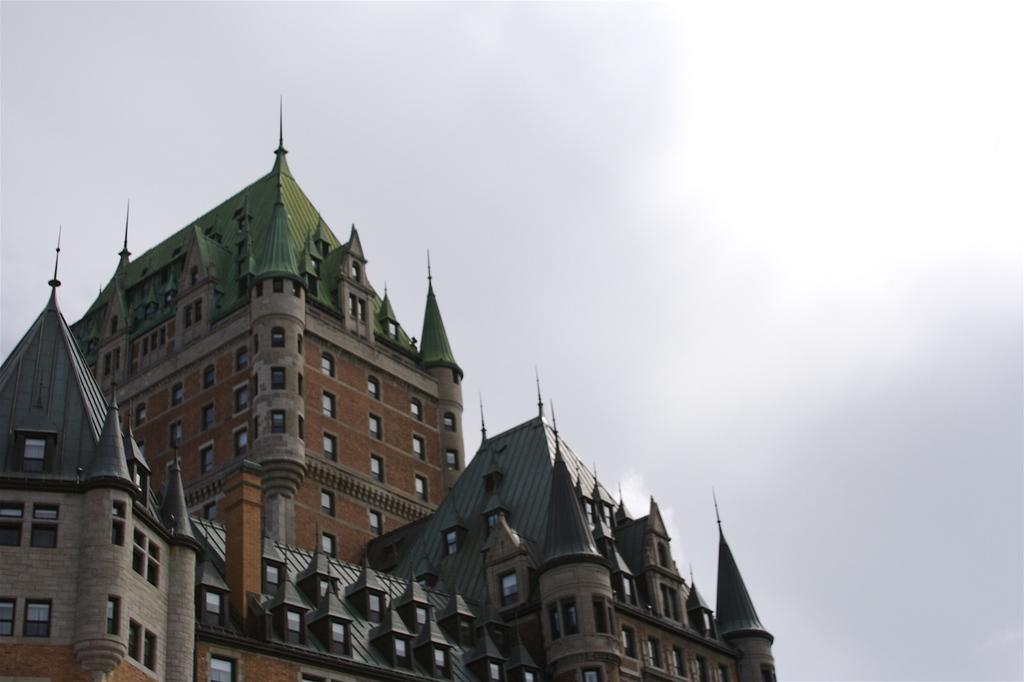How would you summarize this image in a sentence or two? In this image, there is an outside view. In the foreground, there is a castle. In the background, there is a sky. 